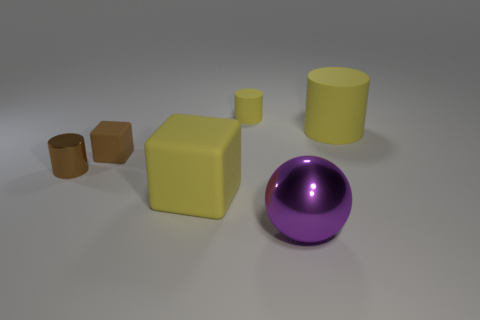Is there a large cylinder made of the same material as the big cube?
Keep it short and to the point. Yes. There is a purple thing that is the same size as the yellow cube; what is its material?
Your answer should be very brief. Metal. Is the number of tiny brown cylinders right of the tiny brown matte thing less than the number of yellow matte objects that are on the right side of the big yellow block?
Your response must be concise. Yes. There is a yellow thing that is both left of the big purple metallic thing and behind the tiny brown matte object; what shape is it?
Give a very brief answer. Cylinder. How many other small shiny things are the same shape as the tiny yellow object?
Provide a succinct answer. 1. The other yellow cube that is the same material as the small block is what size?
Your response must be concise. Large. Are there more small gray metallic spheres than large blocks?
Keep it short and to the point. No. The rubber object that is on the right side of the small matte cylinder is what color?
Provide a succinct answer. Yellow. What is the size of the yellow rubber object that is in front of the small yellow thing and behind the yellow cube?
Give a very brief answer. Large. What number of rubber things are the same size as the purple ball?
Ensure brevity in your answer.  2. 